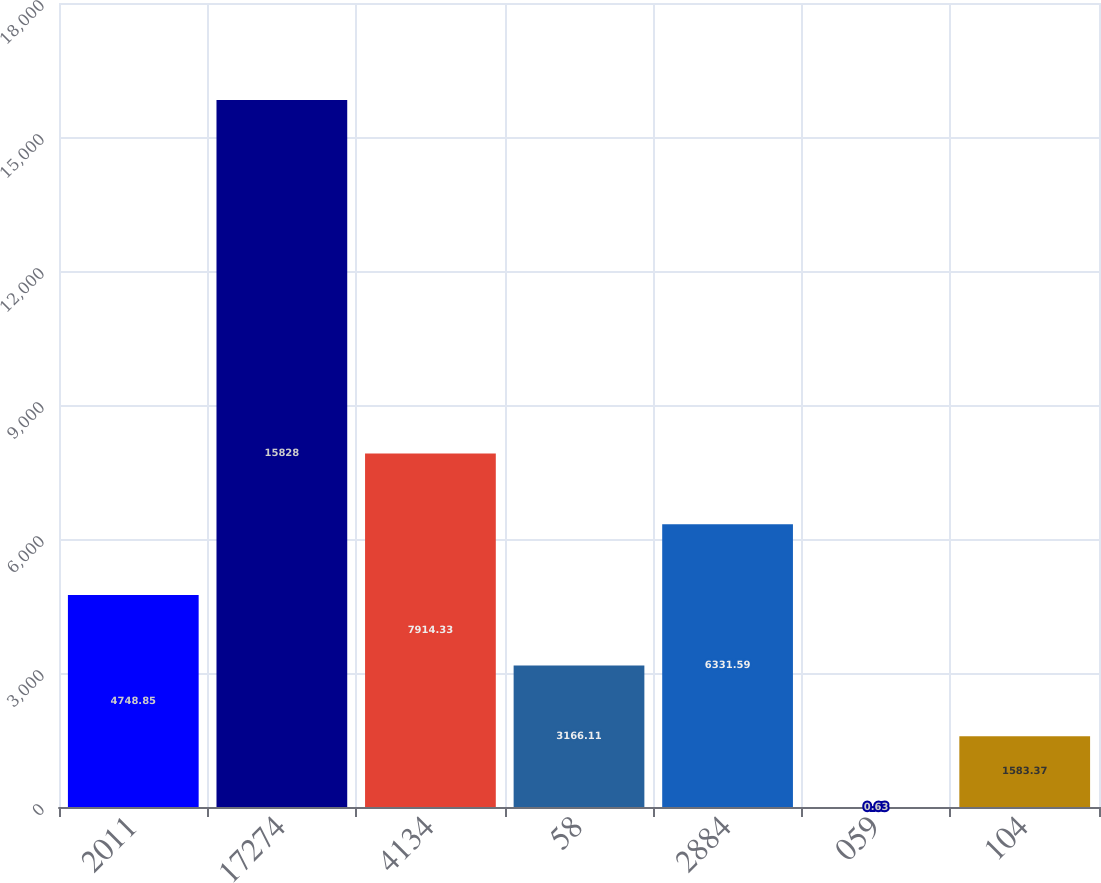<chart> <loc_0><loc_0><loc_500><loc_500><bar_chart><fcel>2011<fcel>17274<fcel>4134<fcel>58<fcel>2884<fcel>059<fcel>104<nl><fcel>4748.85<fcel>15828<fcel>7914.33<fcel>3166.11<fcel>6331.59<fcel>0.63<fcel>1583.37<nl></chart> 